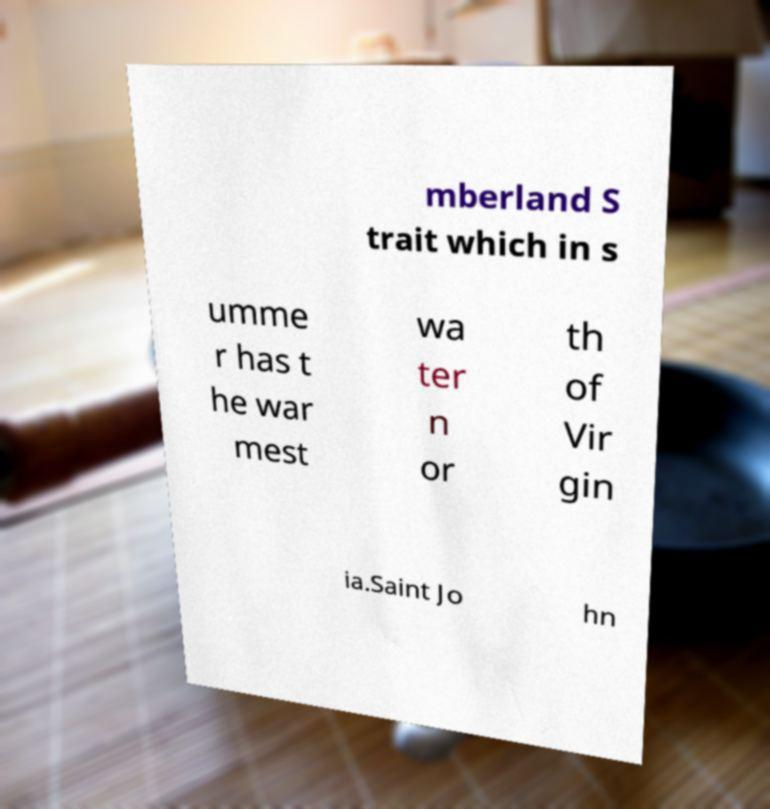What messages or text are displayed in this image? I need them in a readable, typed format. mberland S trait which in s umme r has t he war mest wa ter n or th of Vir gin ia.Saint Jo hn 